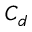<formula> <loc_0><loc_0><loc_500><loc_500>C _ { d }</formula> 